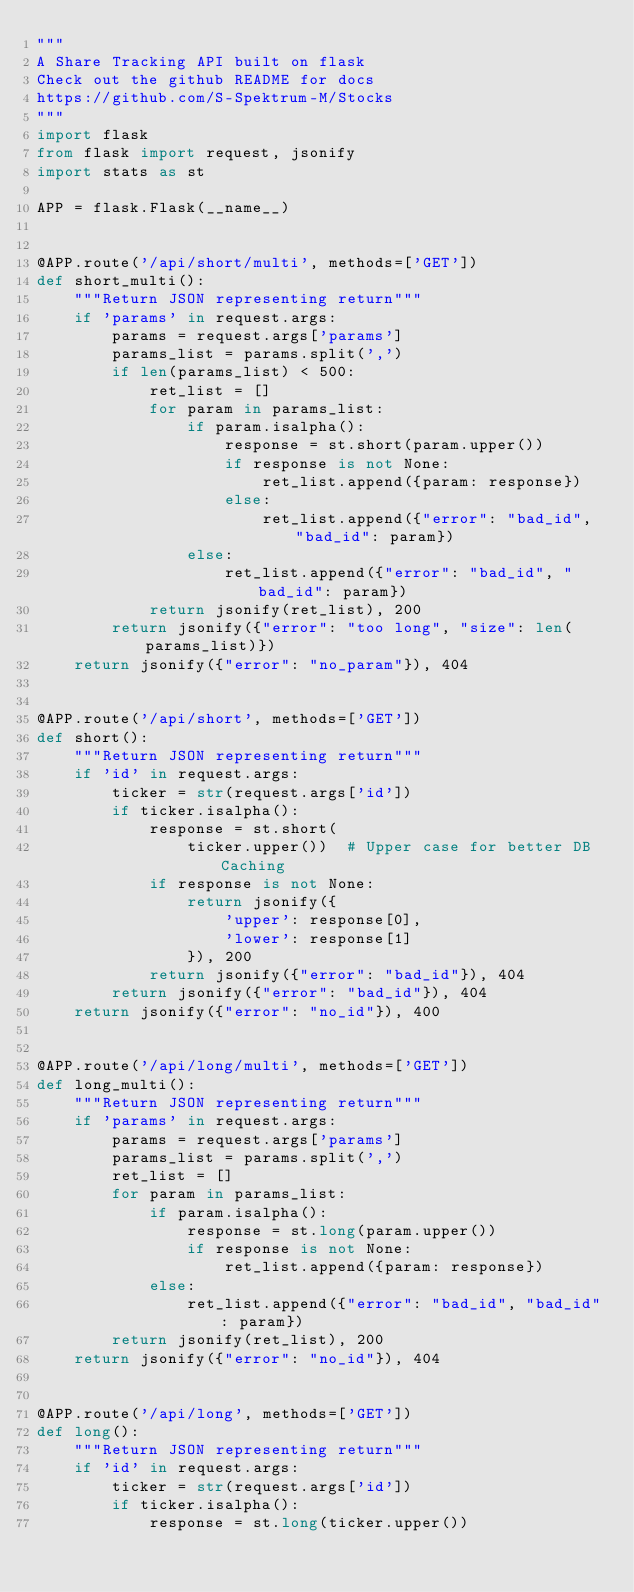<code> <loc_0><loc_0><loc_500><loc_500><_Python_>"""
A Share Tracking API built on flask
Check out the github README for docs
https://github.com/S-Spektrum-M/Stocks
"""
import flask
from flask import request, jsonify
import stats as st

APP = flask.Flask(__name__)


@APP.route('/api/short/multi', methods=['GET'])
def short_multi():
    """Return JSON representing return"""
    if 'params' in request.args:
        params = request.args['params']
        params_list = params.split(',')
        if len(params_list) < 500:
            ret_list = []
            for param in params_list:
                if param.isalpha():
                    response = st.short(param.upper())
                    if response is not None:
                        ret_list.append({param: response})
                    else:
                        ret_list.append({"error": "bad_id", "bad_id": param})
                else:
                    ret_list.append({"error": "bad_id", "bad_id": param})
            return jsonify(ret_list), 200
        return jsonify({"error": "too long", "size": len(params_list)})
    return jsonify({"error": "no_param"}), 404


@APP.route('/api/short', methods=['GET'])
def short():
    """Return JSON representing return"""
    if 'id' in request.args:
        ticker = str(request.args['id'])
        if ticker.isalpha():
            response = st.short(
                ticker.upper())  # Upper case for better DB Caching
            if response is not None:
                return jsonify({
                    'upper': response[0],
                    'lower': response[1]
                }), 200
            return jsonify({"error": "bad_id"}), 404
        return jsonify({"error": "bad_id"}), 404
    return jsonify({"error": "no_id"}), 400


@APP.route('/api/long/multi', methods=['GET'])
def long_multi():
    """Return JSON representing return"""
    if 'params' in request.args:
        params = request.args['params']
        params_list = params.split(',')
        ret_list = []
        for param in params_list:
            if param.isalpha():
                response = st.long(param.upper())
                if response is not None:
                    ret_list.append({param: response})
            else:
                ret_list.append({"error": "bad_id", "bad_id": param})
        return jsonify(ret_list), 200
    return jsonify({"error": "no_id"}), 404


@APP.route('/api/long', methods=['GET'])
def long():
    """Return JSON representing return"""
    if 'id' in request.args:
        ticker = str(request.args['id'])
        if ticker.isalpha():
            response = st.long(ticker.upper())</code> 